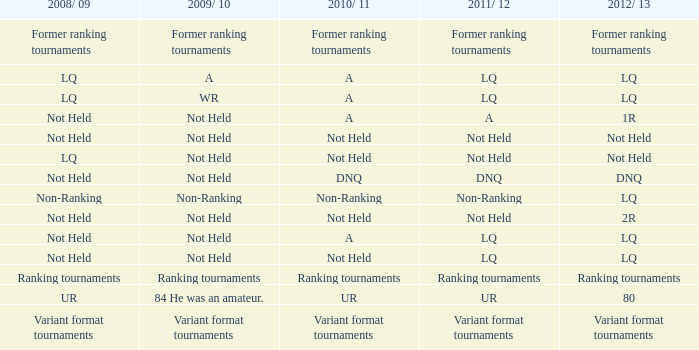What 2010/ 11 has not held as 2009/ 10, and 1r as the 2012/ 13? A. 